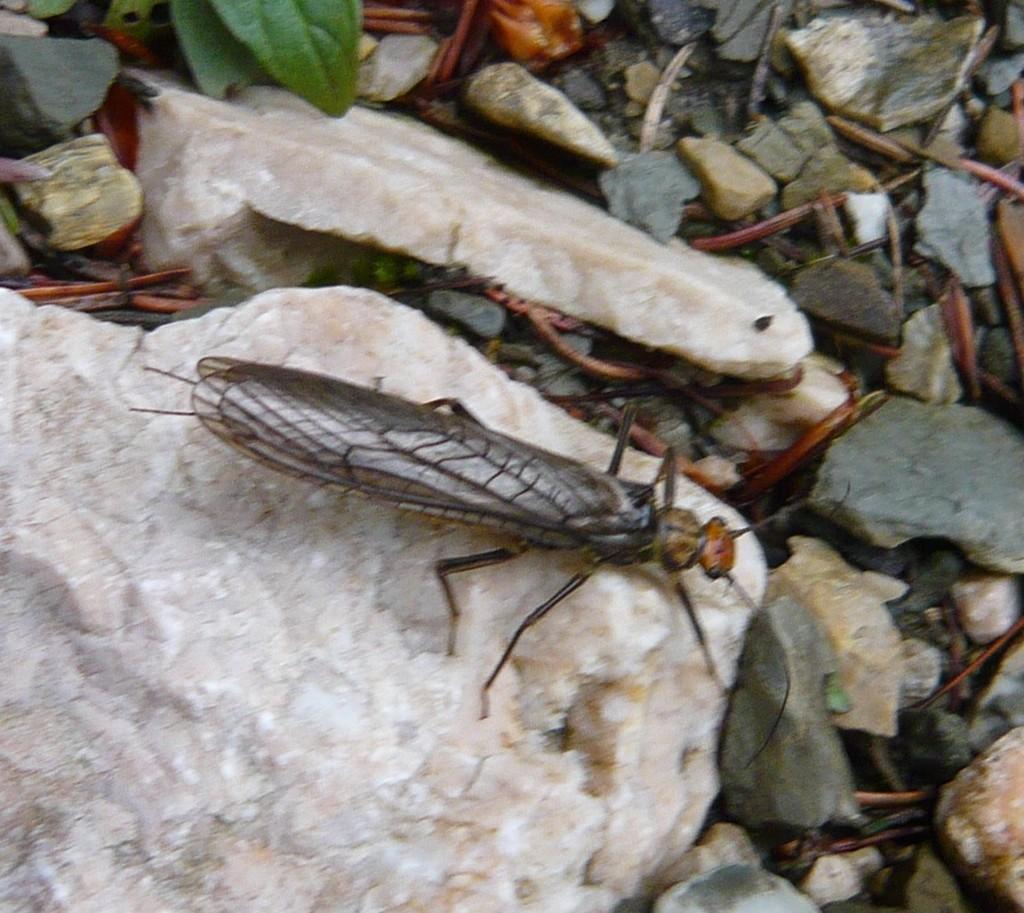Describe this image in one or two sentences. In this image in the front there is an insect and there are stones and there are leaves. 